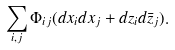<formula> <loc_0><loc_0><loc_500><loc_500>\sum _ { i , j } \Phi _ { i j } ( d x _ { i } d x _ { j } + d z _ { i } d \bar { z } _ { j } ) .</formula> 